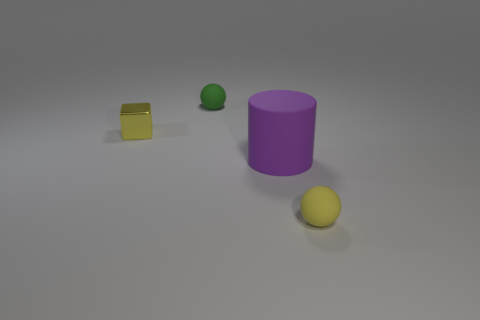There is a metal cube; is it the same color as the small matte thing that is behind the big purple cylinder?
Provide a short and direct response. No. What color is the big rubber object?
Offer a terse response. Purple. What number of objects are either tiny shiny objects or small purple shiny cylinders?
Make the answer very short. 1. What is the material of the yellow thing that is the same size as the yellow ball?
Make the answer very short. Metal. There is a thing in front of the purple matte object; what is its size?
Keep it short and to the point. Small. What is the material of the cube?
Your answer should be compact. Metal. How many objects are objects in front of the tiny green rubber thing or things that are behind the tiny yellow cube?
Your answer should be very brief. 4. How many other objects are the same color as the large thing?
Keep it short and to the point. 0. Is the shape of the purple matte thing the same as the yellow thing that is right of the green sphere?
Ensure brevity in your answer.  No. Is the number of yellow matte balls that are left of the big purple matte cylinder less than the number of small green balls left of the metallic cube?
Your response must be concise. No. 